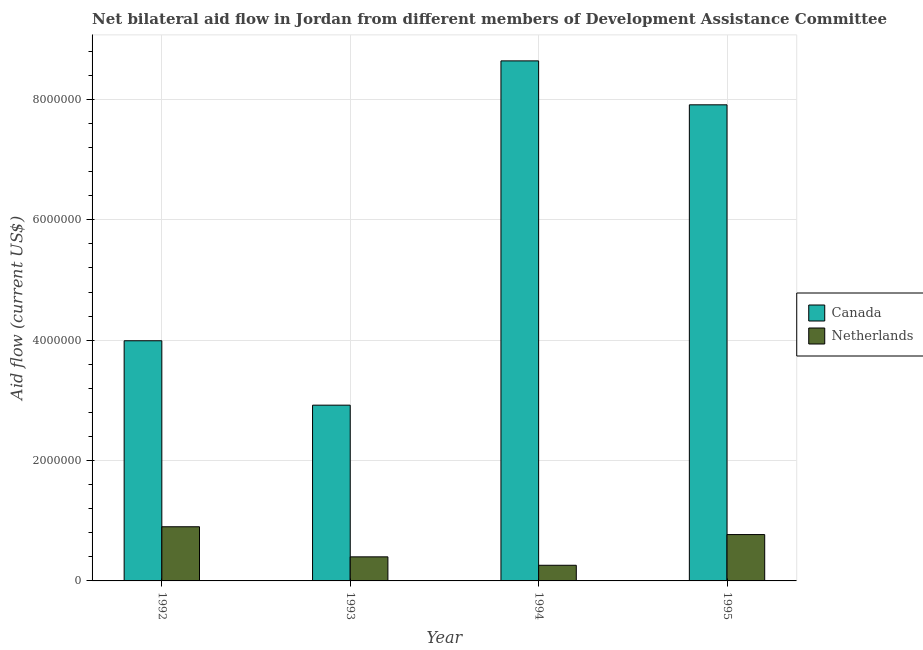How many groups of bars are there?
Your response must be concise. 4. In how many cases, is the number of bars for a given year not equal to the number of legend labels?
Offer a very short reply. 0. What is the amount of aid given by canada in 1995?
Make the answer very short. 7.91e+06. Across all years, what is the maximum amount of aid given by netherlands?
Your answer should be very brief. 9.00e+05. Across all years, what is the minimum amount of aid given by canada?
Make the answer very short. 2.92e+06. In which year was the amount of aid given by netherlands maximum?
Provide a succinct answer. 1992. What is the total amount of aid given by canada in the graph?
Provide a succinct answer. 2.35e+07. What is the difference between the amount of aid given by netherlands in 1994 and that in 1995?
Offer a very short reply. -5.10e+05. What is the difference between the amount of aid given by netherlands in 1994 and the amount of aid given by canada in 1992?
Your response must be concise. -6.40e+05. What is the average amount of aid given by canada per year?
Make the answer very short. 5.86e+06. In the year 1993, what is the difference between the amount of aid given by netherlands and amount of aid given by canada?
Give a very brief answer. 0. In how many years, is the amount of aid given by netherlands greater than 5600000 US$?
Your answer should be compact. 0. What is the ratio of the amount of aid given by canada in 1993 to that in 1995?
Give a very brief answer. 0.37. Is the amount of aid given by netherlands in 1993 less than that in 1995?
Keep it short and to the point. Yes. What is the difference between the highest and the lowest amount of aid given by netherlands?
Ensure brevity in your answer.  6.40e+05. In how many years, is the amount of aid given by canada greater than the average amount of aid given by canada taken over all years?
Your answer should be very brief. 2. What does the 1st bar from the left in 1994 represents?
Offer a very short reply. Canada. What does the 1st bar from the right in 1995 represents?
Offer a terse response. Netherlands. How many years are there in the graph?
Make the answer very short. 4. Are the values on the major ticks of Y-axis written in scientific E-notation?
Provide a succinct answer. No. How many legend labels are there?
Ensure brevity in your answer.  2. How are the legend labels stacked?
Provide a short and direct response. Vertical. What is the title of the graph?
Make the answer very short. Net bilateral aid flow in Jordan from different members of Development Assistance Committee. Does "Unregistered firms" appear as one of the legend labels in the graph?
Offer a terse response. No. What is the label or title of the X-axis?
Offer a terse response. Year. What is the Aid flow (current US$) in Canada in 1992?
Provide a succinct answer. 3.99e+06. What is the Aid flow (current US$) in Canada in 1993?
Offer a terse response. 2.92e+06. What is the Aid flow (current US$) in Netherlands in 1993?
Offer a very short reply. 4.00e+05. What is the Aid flow (current US$) of Canada in 1994?
Offer a terse response. 8.64e+06. What is the Aid flow (current US$) of Netherlands in 1994?
Ensure brevity in your answer.  2.60e+05. What is the Aid flow (current US$) of Canada in 1995?
Ensure brevity in your answer.  7.91e+06. What is the Aid flow (current US$) of Netherlands in 1995?
Give a very brief answer. 7.70e+05. Across all years, what is the maximum Aid flow (current US$) of Canada?
Your response must be concise. 8.64e+06. Across all years, what is the minimum Aid flow (current US$) in Canada?
Ensure brevity in your answer.  2.92e+06. Across all years, what is the minimum Aid flow (current US$) of Netherlands?
Your answer should be compact. 2.60e+05. What is the total Aid flow (current US$) of Canada in the graph?
Your answer should be compact. 2.35e+07. What is the total Aid flow (current US$) of Netherlands in the graph?
Offer a very short reply. 2.33e+06. What is the difference between the Aid flow (current US$) of Canada in 1992 and that in 1993?
Give a very brief answer. 1.07e+06. What is the difference between the Aid flow (current US$) of Canada in 1992 and that in 1994?
Offer a very short reply. -4.65e+06. What is the difference between the Aid flow (current US$) in Netherlands in 1992 and that in 1994?
Make the answer very short. 6.40e+05. What is the difference between the Aid flow (current US$) in Canada in 1992 and that in 1995?
Provide a short and direct response. -3.92e+06. What is the difference between the Aid flow (current US$) of Canada in 1993 and that in 1994?
Provide a short and direct response. -5.72e+06. What is the difference between the Aid flow (current US$) of Canada in 1993 and that in 1995?
Your answer should be compact. -4.99e+06. What is the difference between the Aid flow (current US$) in Netherlands in 1993 and that in 1995?
Offer a very short reply. -3.70e+05. What is the difference between the Aid flow (current US$) in Canada in 1994 and that in 1995?
Keep it short and to the point. 7.30e+05. What is the difference between the Aid flow (current US$) in Netherlands in 1994 and that in 1995?
Provide a short and direct response. -5.10e+05. What is the difference between the Aid flow (current US$) of Canada in 1992 and the Aid flow (current US$) of Netherlands in 1993?
Offer a very short reply. 3.59e+06. What is the difference between the Aid flow (current US$) of Canada in 1992 and the Aid flow (current US$) of Netherlands in 1994?
Give a very brief answer. 3.73e+06. What is the difference between the Aid flow (current US$) in Canada in 1992 and the Aid flow (current US$) in Netherlands in 1995?
Make the answer very short. 3.22e+06. What is the difference between the Aid flow (current US$) of Canada in 1993 and the Aid flow (current US$) of Netherlands in 1994?
Provide a short and direct response. 2.66e+06. What is the difference between the Aid flow (current US$) of Canada in 1993 and the Aid flow (current US$) of Netherlands in 1995?
Keep it short and to the point. 2.15e+06. What is the difference between the Aid flow (current US$) of Canada in 1994 and the Aid flow (current US$) of Netherlands in 1995?
Make the answer very short. 7.87e+06. What is the average Aid flow (current US$) in Canada per year?
Provide a succinct answer. 5.86e+06. What is the average Aid flow (current US$) in Netherlands per year?
Offer a very short reply. 5.82e+05. In the year 1992, what is the difference between the Aid flow (current US$) of Canada and Aid flow (current US$) of Netherlands?
Provide a succinct answer. 3.09e+06. In the year 1993, what is the difference between the Aid flow (current US$) in Canada and Aid flow (current US$) in Netherlands?
Offer a terse response. 2.52e+06. In the year 1994, what is the difference between the Aid flow (current US$) of Canada and Aid flow (current US$) of Netherlands?
Provide a succinct answer. 8.38e+06. In the year 1995, what is the difference between the Aid flow (current US$) of Canada and Aid flow (current US$) of Netherlands?
Provide a succinct answer. 7.14e+06. What is the ratio of the Aid flow (current US$) of Canada in 1992 to that in 1993?
Give a very brief answer. 1.37. What is the ratio of the Aid flow (current US$) of Netherlands in 1992 to that in 1993?
Offer a very short reply. 2.25. What is the ratio of the Aid flow (current US$) of Canada in 1992 to that in 1994?
Your answer should be very brief. 0.46. What is the ratio of the Aid flow (current US$) of Netherlands in 1992 to that in 1994?
Offer a very short reply. 3.46. What is the ratio of the Aid flow (current US$) of Canada in 1992 to that in 1995?
Provide a succinct answer. 0.5. What is the ratio of the Aid flow (current US$) of Netherlands in 1992 to that in 1995?
Your response must be concise. 1.17. What is the ratio of the Aid flow (current US$) in Canada in 1993 to that in 1994?
Make the answer very short. 0.34. What is the ratio of the Aid flow (current US$) in Netherlands in 1993 to that in 1994?
Offer a terse response. 1.54. What is the ratio of the Aid flow (current US$) of Canada in 1993 to that in 1995?
Give a very brief answer. 0.37. What is the ratio of the Aid flow (current US$) in Netherlands in 1993 to that in 1995?
Provide a succinct answer. 0.52. What is the ratio of the Aid flow (current US$) in Canada in 1994 to that in 1995?
Ensure brevity in your answer.  1.09. What is the ratio of the Aid flow (current US$) of Netherlands in 1994 to that in 1995?
Make the answer very short. 0.34. What is the difference between the highest and the second highest Aid flow (current US$) of Canada?
Your answer should be very brief. 7.30e+05. What is the difference between the highest and the lowest Aid flow (current US$) of Canada?
Make the answer very short. 5.72e+06. What is the difference between the highest and the lowest Aid flow (current US$) of Netherlands?
Your response must be concise. 6.40e+05. 